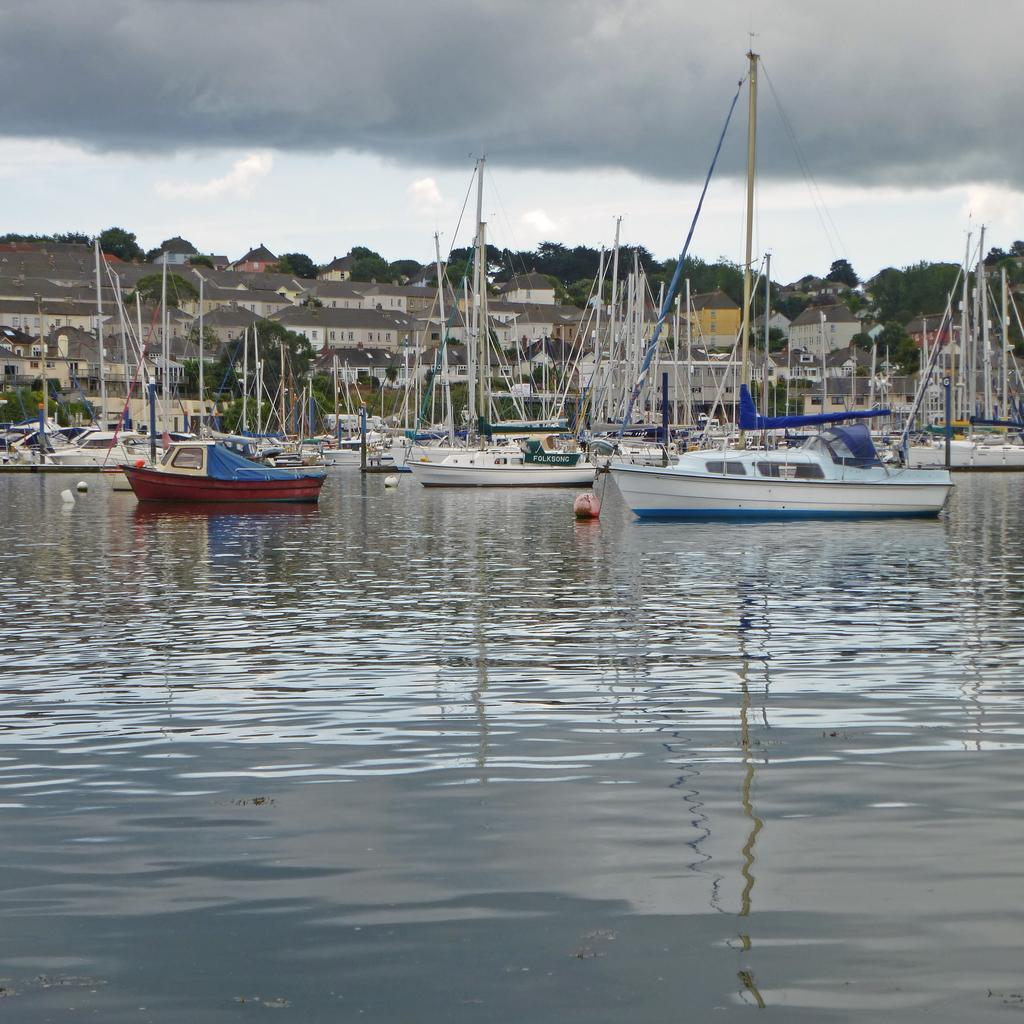What is in the front of the image? There is water in the front of the image. What can be seen in the background of the image? There are boats sailing on the water, buildings, and trees in the background. How would you describe the sky in the image? The sky is cloudy in the image. What type of bell can be heard ringing in the image? There is no bell present in the image, so it is not possible to hear it ringing. 